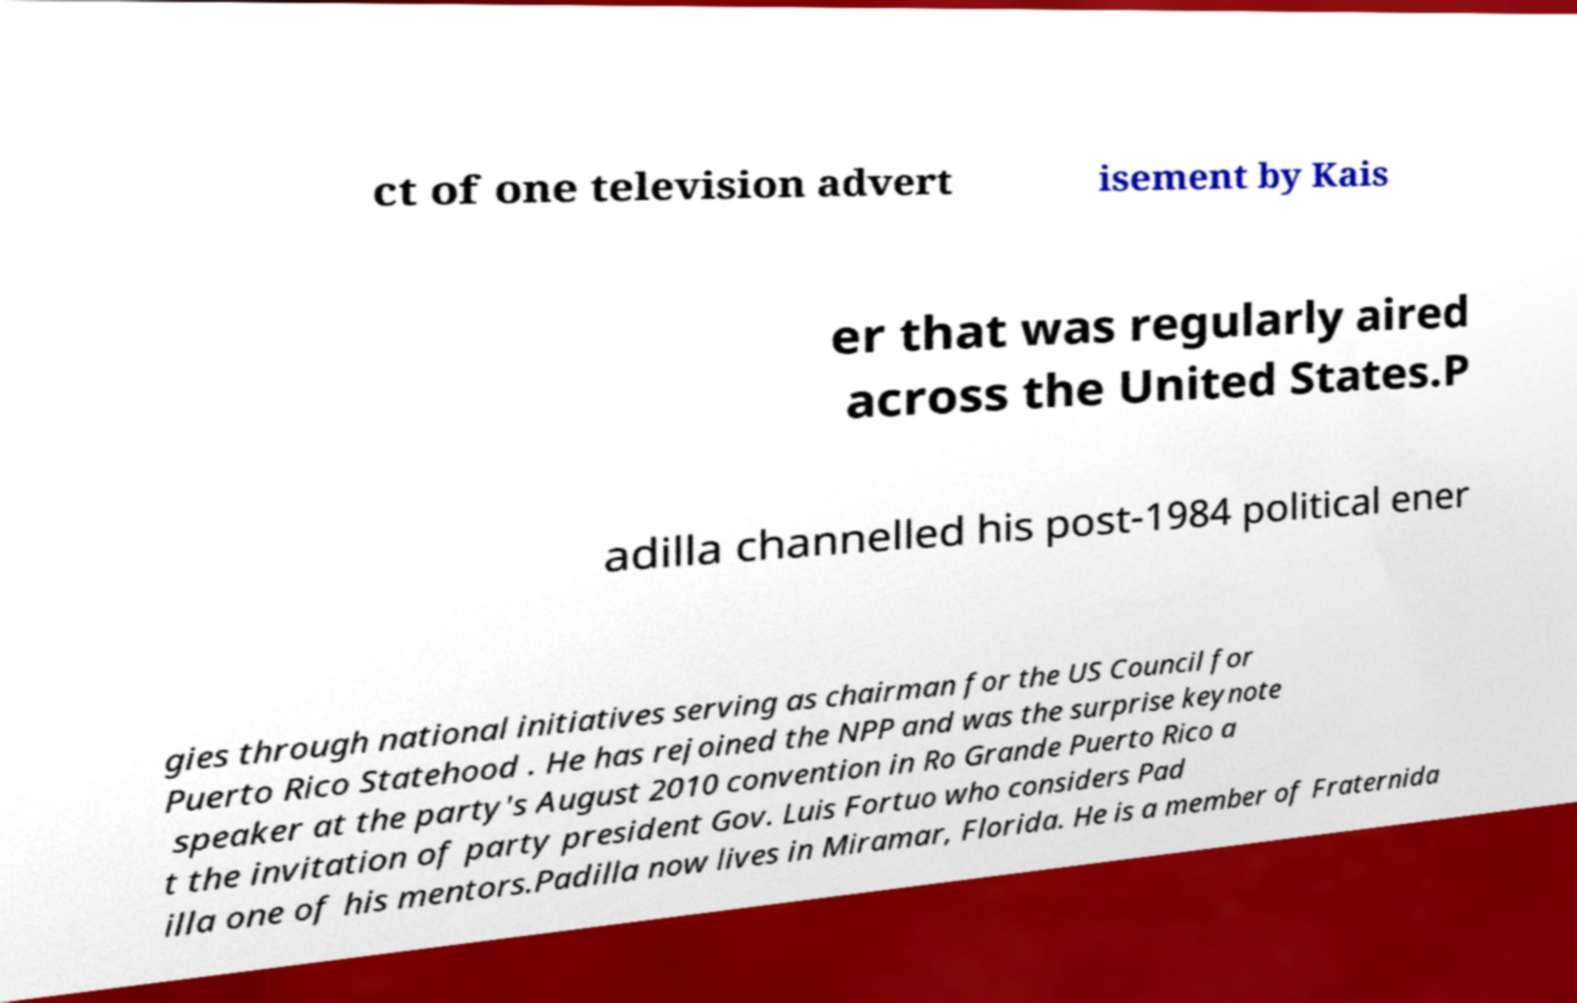Could you extract and type out the text from this image? ct of one television advert isement by Kais er that was regularly aired across the United States.P adilla channelled his post-1984 political ener gies through national initiatives serving as chairman for the US Council for Puerto Rico Statehood . He has rejoined the NPP and was the surprise keynote speaker at the party's August 2010 convention in Ro Grande Puerto Rico a t the invitation of party president Gov. Luis Fortuo who considers Pad illa one of his mentors.Padilla now lives in Miramar, Florida. He is a member of Fraternida 